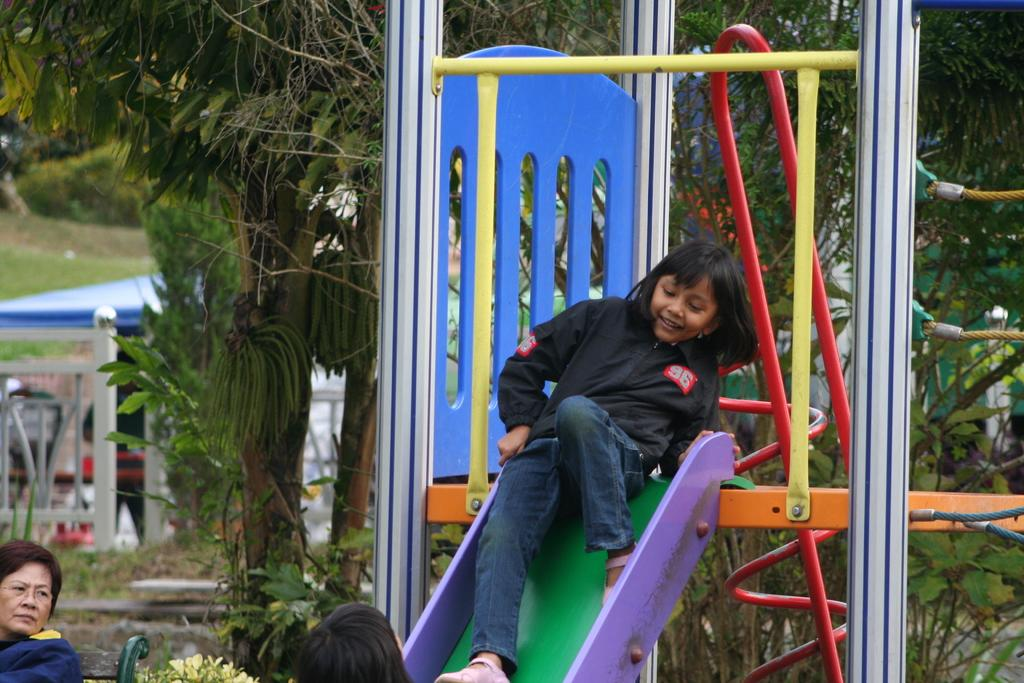What is the girl doing in the image? The girl is sitting on a slide in the image. Who else is present in the image? There is a woman sitting on a bench in the image. What can be seen in the background of the image? There are trees and a tent visible in the background of the image. What type of grape is the girl holding in the image? There is no grape present in the image; the girl is sitting on a slide. Where is the home of the woman in the image? The image does not provide information about the woman's home. 